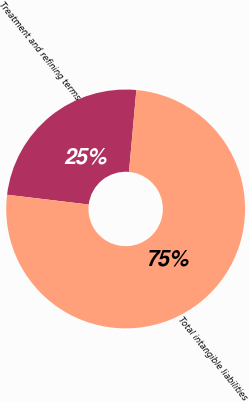<chart> <loc_0><loc_0><loc_500><loc_500><pie_chart><fcel>Treatment and refining terms<fcel>Total intangible liabilities<nl><fcel>24.53%<fcel>75.47%<nl></chart> 